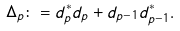<formula> <loc_0><loc_0><loc_500><loc_500>\Delta _ { p } \colon = d _ { p } ^ { * } d _ { p } + d _ { p - 1 } d _ { p - 1 } ^ { * } .</formula> 